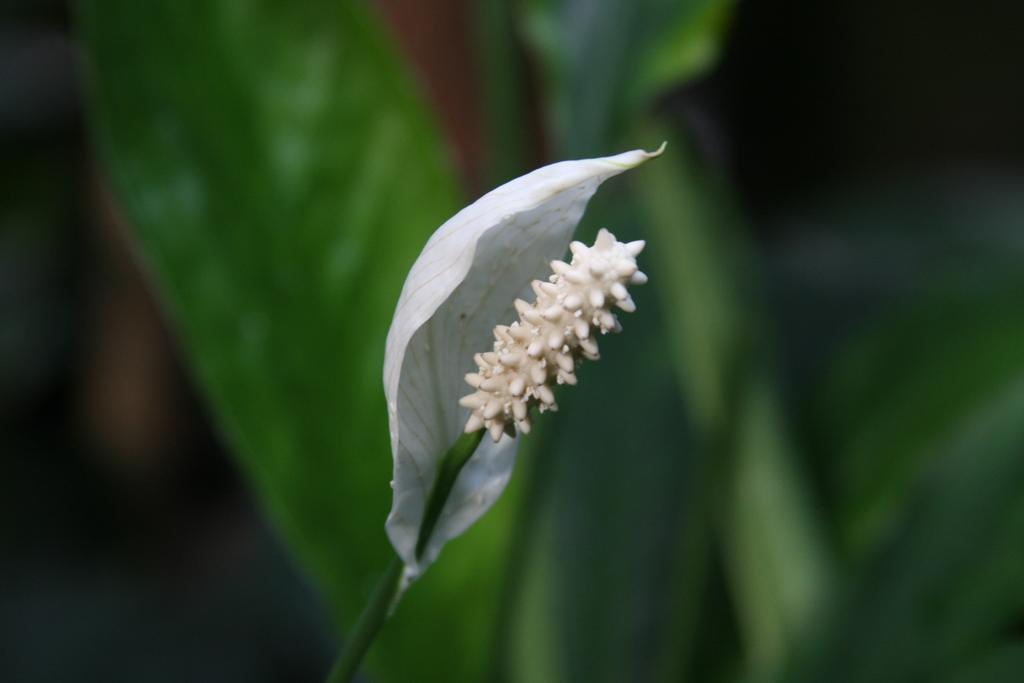How would you summarize this image in a sentence or two? In this picture I can see a flower with a stem, and there is blur background. 